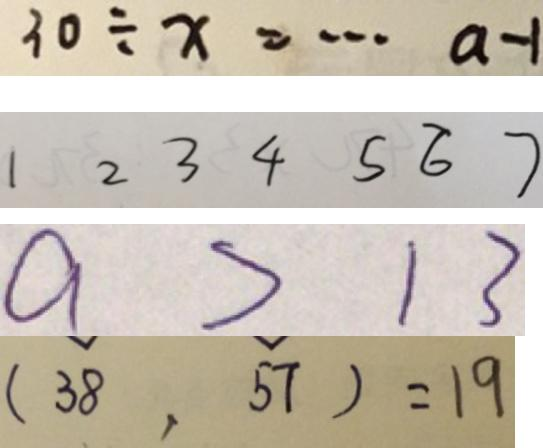Convert formula to latex. <formula><loc_0><loc_0><loc_500><loc_500>3 0 \div x = \cdots a - 1 
 1 2 3 4 5 6 7 
 a > 1 3 
 ( 3 8 , 5 7 ) = 1 9</formula> 